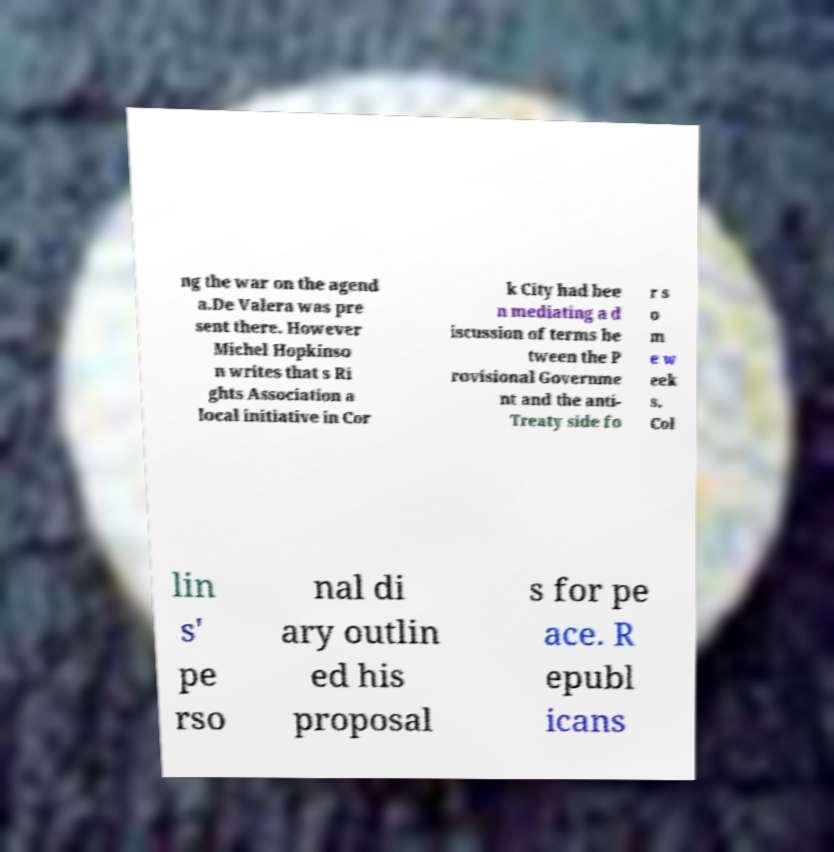I need the written content from this picture converted into text. Can you do that? ng the war on the agend a.De Valera was pre sent there. However Michel Hopkinso n writes that s Ri ghts Association a local initiative in Cor k City had bee n mediating a d iscussion of terms be tween the P rovisional Governme nt and the anti- Treaty side fo r s o m e w eek s. Col lin s' pe rso nal di ary outlin ed his proposal s for pe ace. R epubl icans 